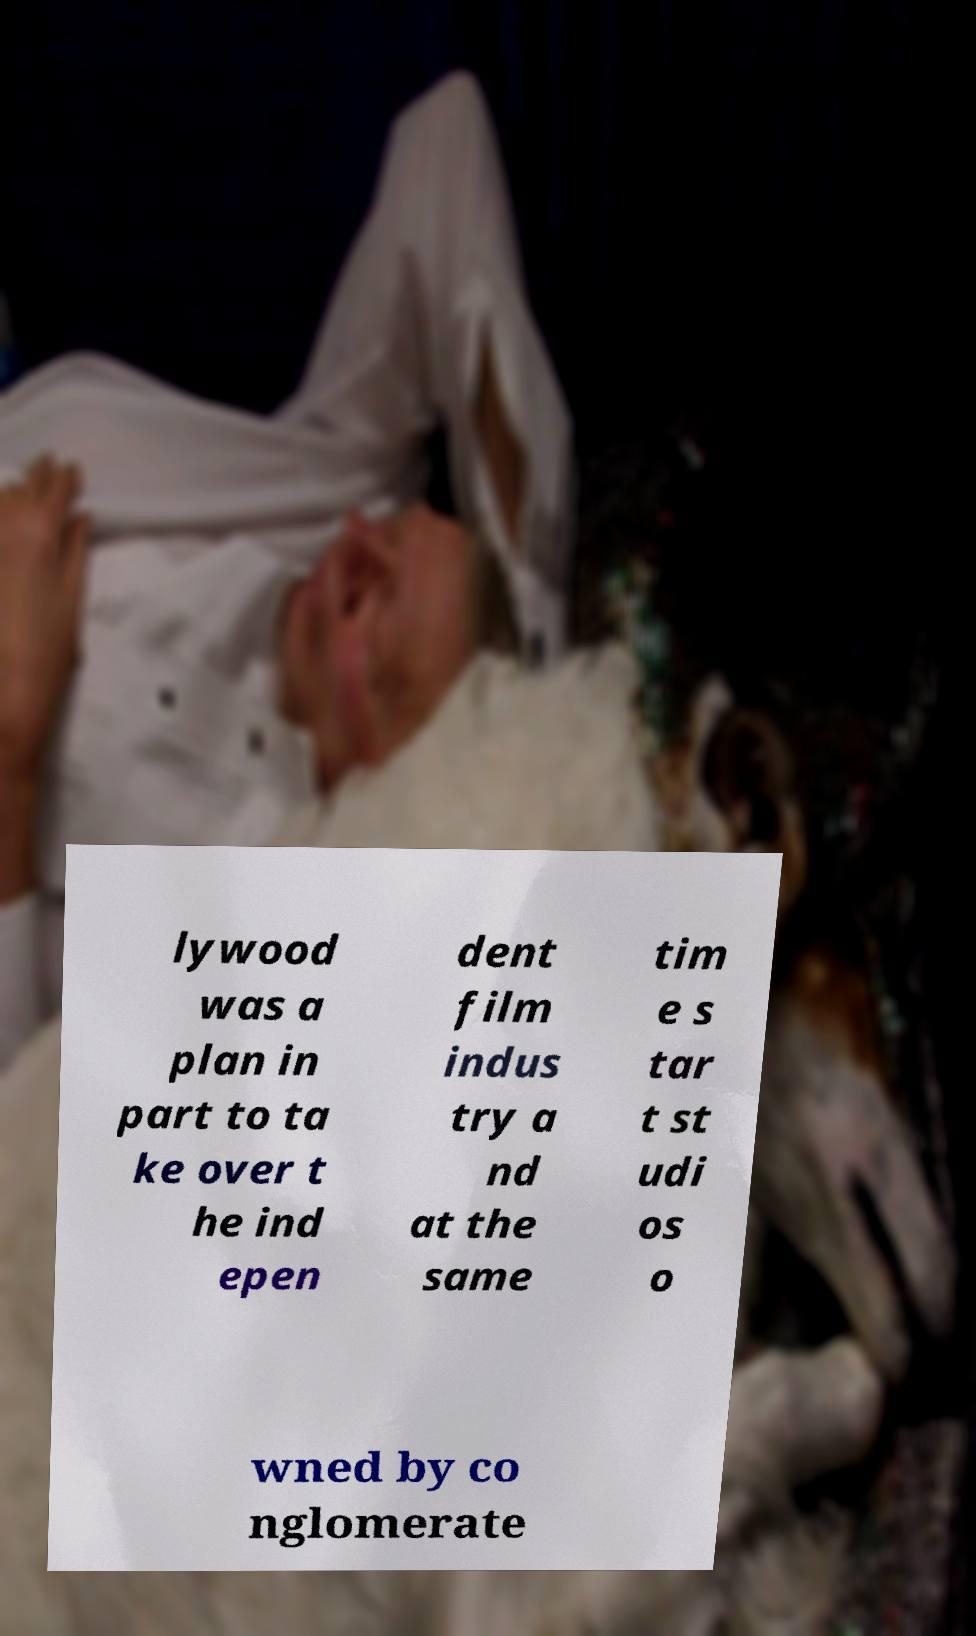Can you read and provide the text displayed in the image?This photo seems to have some interesting text. Can you extract and type it out for me? lywood was a plan in part to ta ke over t he ind epen dent film indus try a nd at the same tim e s tar t st udi os o wned by co nglomerate 